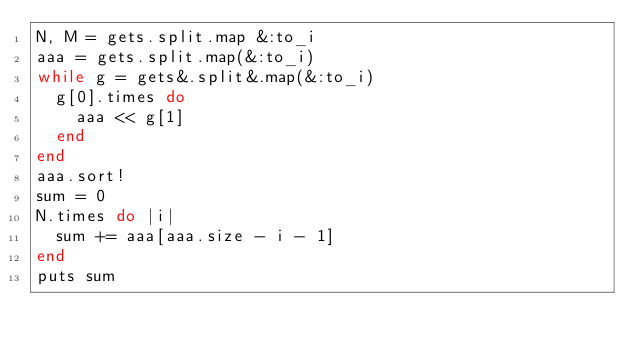Convert code to text. <code><loc_0><loc_0><loc_500><loc_500><_Ruby_>N, M = gets.split.map &:to_i
aaa = gets.split.map(&:to_i)
while g = gets&.split&.map(&:to_i)
  g[0].times do
    aaa << g[1]
  end
end
aaa.sort!
sum = 0
N.times do |i|
  sum += aaa[aaa.size - i - 1]
end
puts sum
</code> 